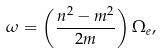<formula> <loc_0><loc_0><loc_500><loc_500>\omega = \left ( \frac { n ^ { 2 } - m ^ { 2 } } { 2 m } \right ) \Omega _ { e } ,</formula> 